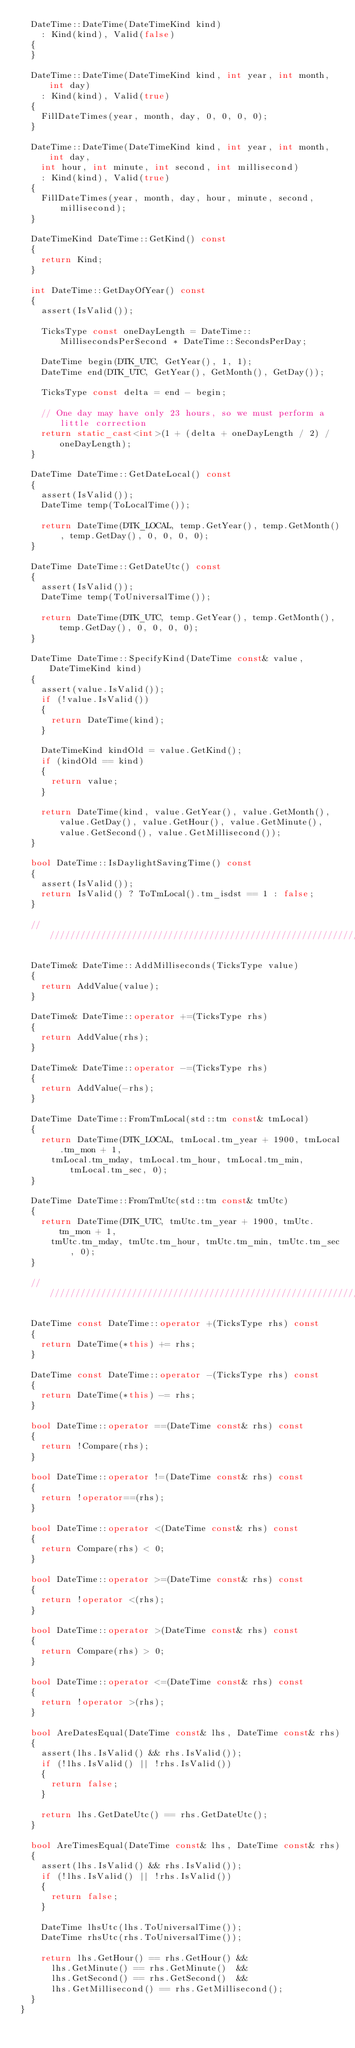<code> <loc_0><loc_0><loc_500><loc_500><_C++_>  DateTime::DateTime(DateTimeKind kind) 
    : Kind(kind), Valid(false)
  {
  }

  DateTime::DateTime(DateTimeKind kind, int year, int month, int day) 
    : Kind(kind), Valid(true)
  {
    FillDateTimes(year, month, day, 0, 0, 0, 0);
  }

  DateTime::DateTime(DateTimeKind kind, int year, int month, int day, 
    int hour, int minute, int second, int millisecond)
    : Kind(kind), Valid(true)
  {
    FillDateTimes(year, month, day, hour, minute, second, millisecond);
  }

  DateTimeKind DateTime::GetKind() const
  {
    return Kind;
  }

  int DateTime::GetDayOfYear() const
  {
    assert(IsValid());

    TicksType const oneDayLength = DateTime::MillisecondsPerSecond * DateTime::SecondsPerDay;

    DateTime begin(DTK_UTC, GetYear(), 1, 1);
    DateTime end(DTK_UTC, GetYear(), GetMonth(), GetDay());

    TicksType const delta = end - begin;

    // One day may have only 23 hours, so we must perform a little correction
    return static_cast<int>(1 + (delta + oneDayLength / 2) / oneDayLength);
  }

  DateTime DateTime::GetDateLocal() const
  {
    assert(IsValid());
    DateTime temp(ToLocalTime());

    return DateTime(DTK_LOCAL, temp.GetYear(), temp.GetMonth(), temp.GetDay(), 0, 0, 0, 0);
  }

  DateTime DateTime::GetDateUtc() const
  {
    assert(IsValid());
    DateTime temp(ToUniversalTime());

    return DateTime(DTK_UTC, temp.GetYear(), temp.GetMonth(), temp.GetDay(), 0, 0, 0, 0);
  }

  DateTime DateTime::SpecifyKind(DateTime const& value, DateTimeKind kind)
  {
    assert(value.IsValid());
    if (!value.IsValid())
    {
      return DateTime(kind);
    }

    DateTimeKind kindOld = value.GetKind();
    if (kindOld == kind)
    {
      return value;
    }

    return DateTime(kind, value.GetYear(), value.GetMonth(), value.GetDay(), value.GetHour(), value.GetMinute(), value.GetSecond(), value.GetMillisecond());
  }

  bool DateTime::IsDaylightSavingTime() const
  {
    assert(IsValid());
    return IsValid() ? ToTmLocal().tm_isdst == 1 : false;
  }

  //////////////////////////////////////////////////////////////////////////

  DateTime& DateTime::AddMilliseconds(TicksType value)
  {
    return AddValue(value);
  }

  DateTime& DateTime::operator +=(TicksType rhs)
  {
    return AddValue(rhs);
  }

  DateTime& DateTime::operator -=(TicksType rhs)
  {
    return AddValue(-rhs);
  }

  DateTime DateTime::FromTmLocal(std::tm const& tmLocal)
  {
    return DateTime(DTK_LOCAL, tmLocal.tm_year + 1900, tmLocal.tm_mon + 1,
      tmLocal.tm_mday, tmLocal.tm_hour, tmLocal.tm_min, tmLocal.tm_sec, 0);
  }

  DateTime DateTime::FromTmUtc(std::tm const& tmUtc)
  {
    return DateTime(DTK_UTC, tmUtc.tm_year + 1900, tmUtc.tm_mon + 1,
      tmUtc.tm_mday, tmUtc.tm_hour, tmUtc.tm_min, tmUtc.tm_sec, 0);
  }

  //////////////////////////////////////////////////////////////////////////

  DateTime const DateTime::operator +(TicksType rhs) const
  {
    return DateTime(*this) += rhs;
  }

  DateTime const DateTime::operator -(TicksType rhs) const
  {
    return DateTime(*this) -= rhs;
  }

  bool DateTime::operator ==(DateTime const& rhs) const
  {
    return !Compare(rhs);
  }

  bool DateTime::operator !=(DateTime const& rhs) const
  {
    return !operator==(rhs);
  }

  bool DateTime::operator <(DateTime const& rhs) const
  {
    return Compare(rhs) < 0;
  }

  bool DateTime::operator >=(DateTime const& rhs) const
  {
    return !operator <(rhs);
  }

  bool DateTime::operator >(DateTime const& rhs) const
  {
    return Compare(rhs) > 0;
  }

  bool DateTime::operator <=(DateTime const& rhs) const
  {
    return !operator >(rhs);
  }

  bool AreDatesEqual(DateTime const& lhs, DateTime const& rhs)
  {
    assert(lhs.IsValid() && rhs.IsValid());
    if (!lhs.IsValid() || !rhs.IsValid())
    {
      return false;
    }

    return lhs.GetDateUtc() == rhs.GetDateUtc();
  }

  bool AreTimesEqual(DateTime const& lhs, DateTime const& rhs)
  {
    assert(lhs.IsValid() && rhs.IsValid());
    if (!lhs.IsValid() || !rhs.IsValid())
    {
      return false;
    }

    DateTime lhsUtc(lhs.ToUniversalTime());
    DateTime rhsUtc(rhs.ToUniversalTime());

    return lhs.GetHour() == rhs.GetHour() &&
      lhs.GetMinute() == rhs.GetMinute()  &&
      lhs.GetSecond() == rhs.GetSecond()  &&
      lhs.GetMillisecond() == rhs.GetMillisecond();
  }
}
</code> 